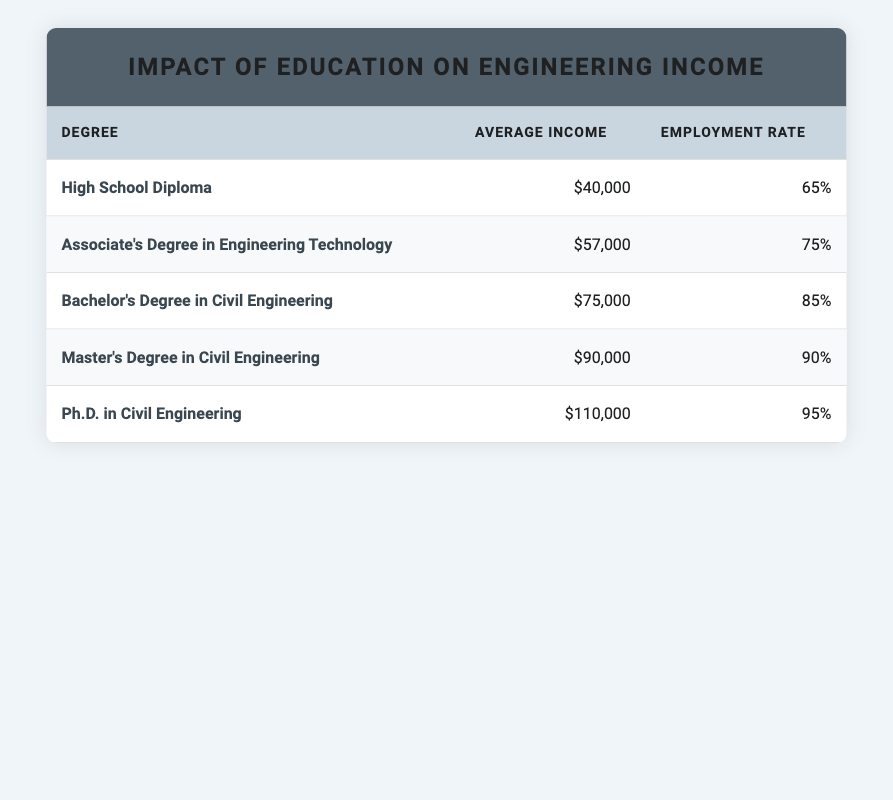What is the average income for someone with a Bachelor's Degree in Civil Engineering? The table states that the average income for someone with a Bachelor's Degree in Civil Engineering is listed directly in the corresponding row. It is 75,000.
Answer: 75,000 What is the employment rate for individuals with a Master's Degree in Civil Engineering? From the table, the employment rate is directly indicated in the row for the Master's Degree in Civil Engineering, which shows an employment rate of 90.
Answer: 90 Which degree has the highest average income? By comparing the average income values across all educational levels in the table, the highest value is found next to the Ph.D. in Civil Engineering, with an average income of 110,000.
Answer: Ph.D. in Civil Engineering What is the difference in employment rates between those with a High School Diploma and those with a Master's Degree? The employment rate for a High School Diploma is 65, and for a Master's Degree, it is 90. To find the difference, we subtract: 90 - 65 = 25.
Answer: 25 Is it true that earning an Associate's Degree leads to a higher average income than a High School Diploma? The average income listed for an Associate's Degree in Engineering Technology is 57,000, while for a High School Diploma it is 40,000. Since 57,000 is greater than 40,000, the statement is true.
Answer: Yes If you add the average incomes for a Bachelor's Degree and Master's Degree, what do you get? The average income for a Bachelor's Degree in Civil Engineering is 75,000 and for a Master's Degree is 90,000. Summing these gives: 75,000 + 90,000 = 165,000.
Answer: 165,000 Which degree shows the lowest employment rate? By reviewing each employment rate provided in the table, the lowest value is 65%, which is associated with the High School Diploma.
Answer: High School Diploma Is it accurate to say that each higher education level results in an increased employment rate? To verify this, we can examine the employment rates: 65, 75, 85, 90, and 95. We see that each successive level has a higher rate, indicating that the statement is accurate.
Answer: Yes What is the average income for degrees below a Bachelor's Degree? The average incomes below a Bachelor's Degree are for High School Diploma (40,000) and Associate's Degree in Engineering Technology (57,000). The average is calculated as: (40,000 + 57,000) / 2 = 48,500.
Answer: 48,500 